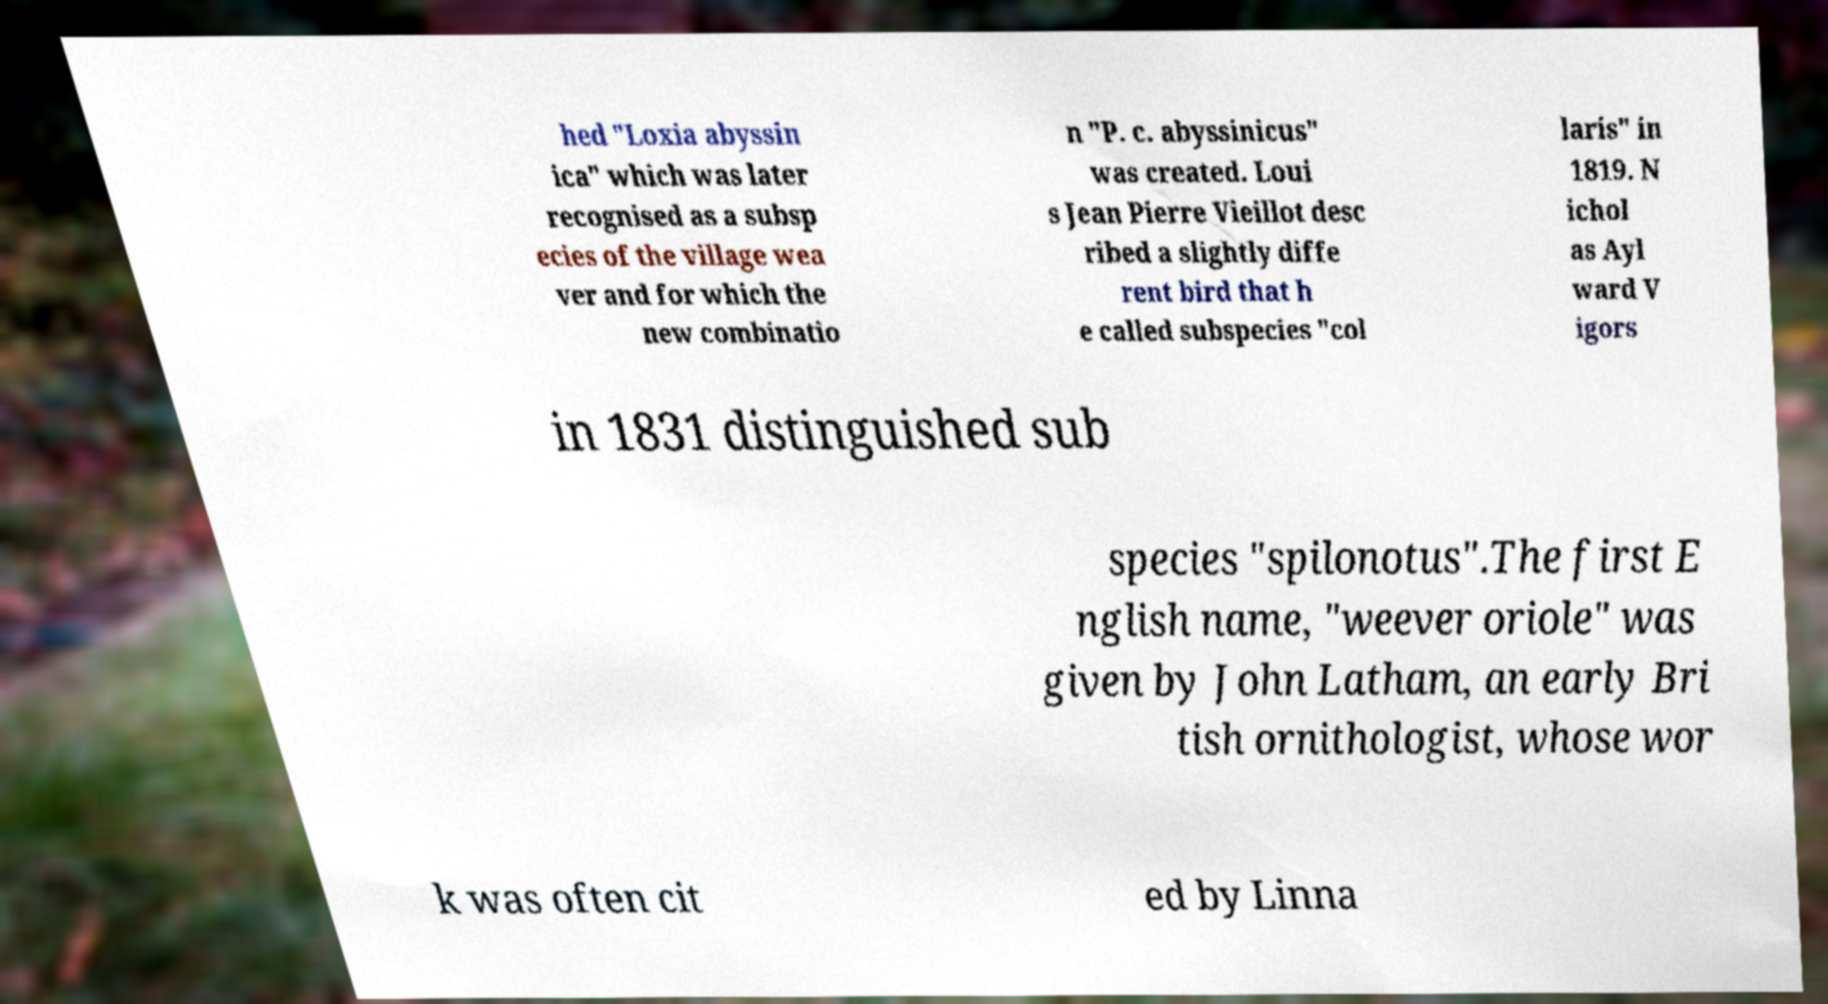I need the written content from this picture converted into text. Can you do that? hed "Loxia abyssin ica" which was later recognised as a subsp ecies of the village wea ver and for which the new combinatio n "P. c. abyssinicus" was created. Loui s Jean Pierre Vieillot desc ribed a slightly diffe rent bird that h e called subspecies "col laris" in 1819. N ichol as Ayl ward V igors in 1831 distinguished sub species "spilonotus".The first E nglish name, "weever oriole" was given by John Latham, an early Bri tish ornithologist, whose wor k was often cit ed by Linna 